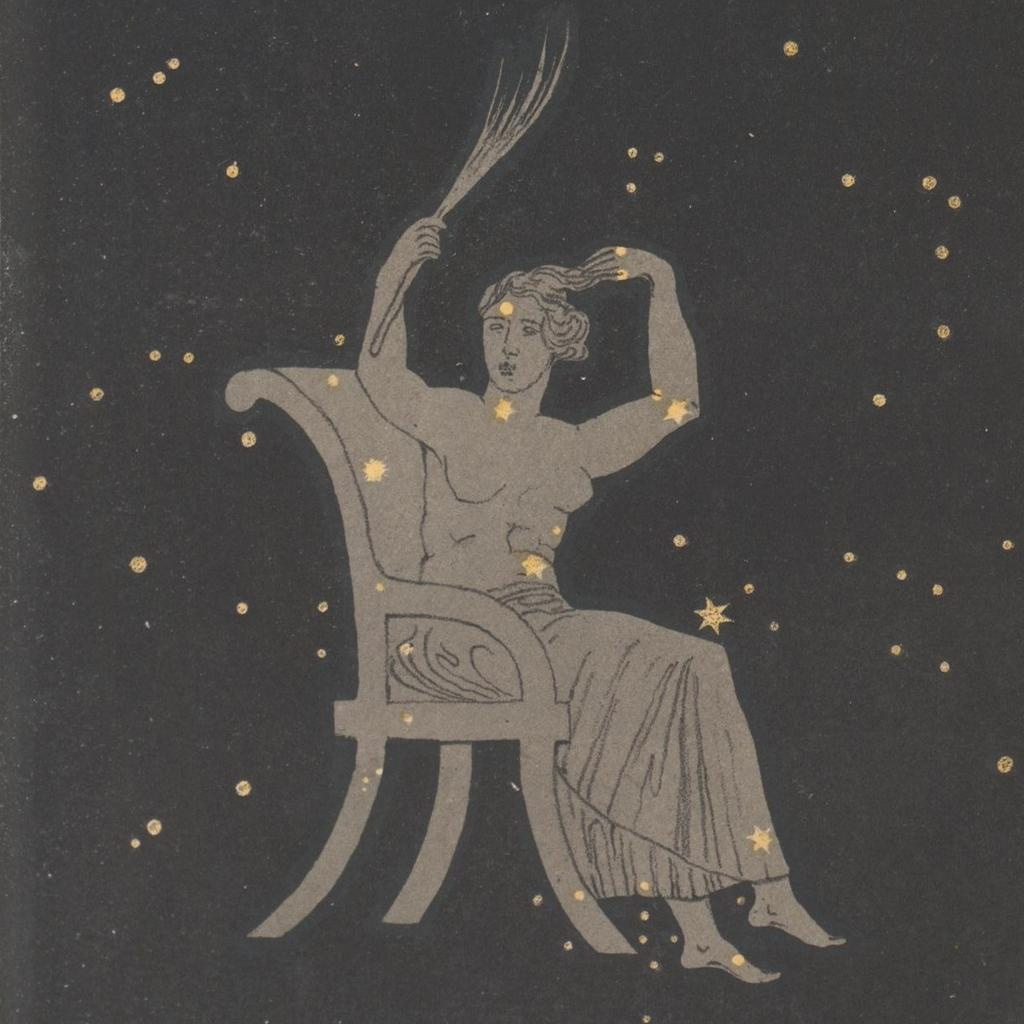What is the main subject of the image? There is a painting in the image. What is the person in the painting doing? The painting depicts a person sitting in a chair. What color is the background of the painting? The background of the painting is black. What additional elements are present in the painting? There are gold stars and dots in the painting. How far away is the robin from the painting in the image? There is no robin present in the image, so it cannot be determined how far away it might be. 